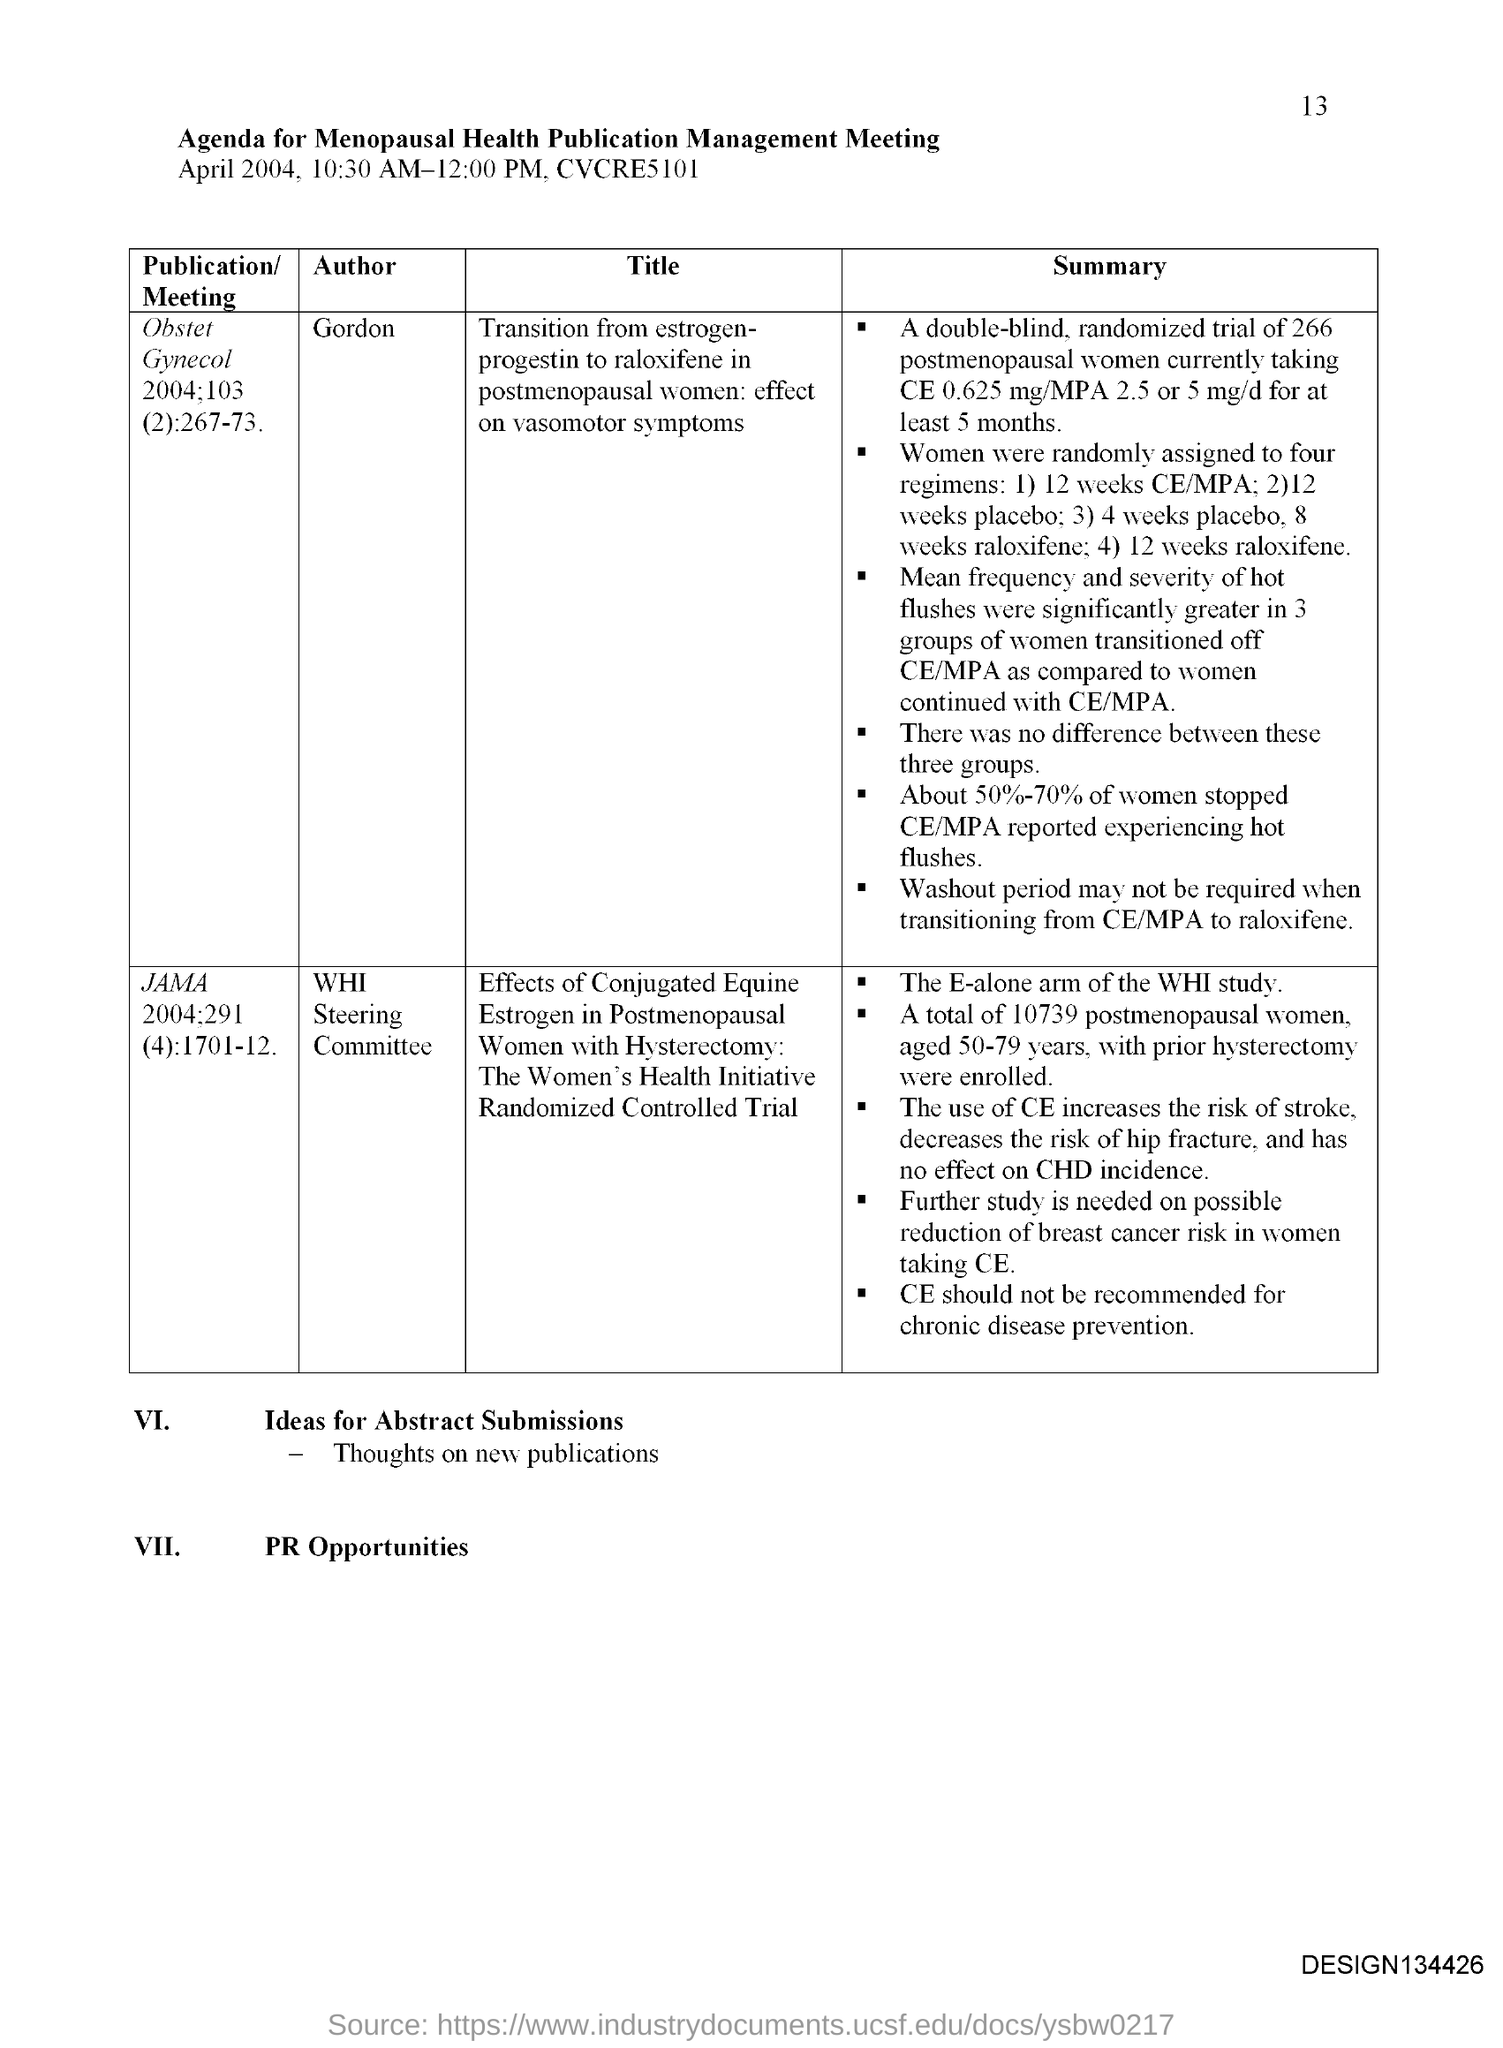What is the page no mentioned in this document?
Offer a terse response. 13. What agenda is given here?
Your answer should be very brief. Agenda for Menopausal Health Publication Management Meeting. 